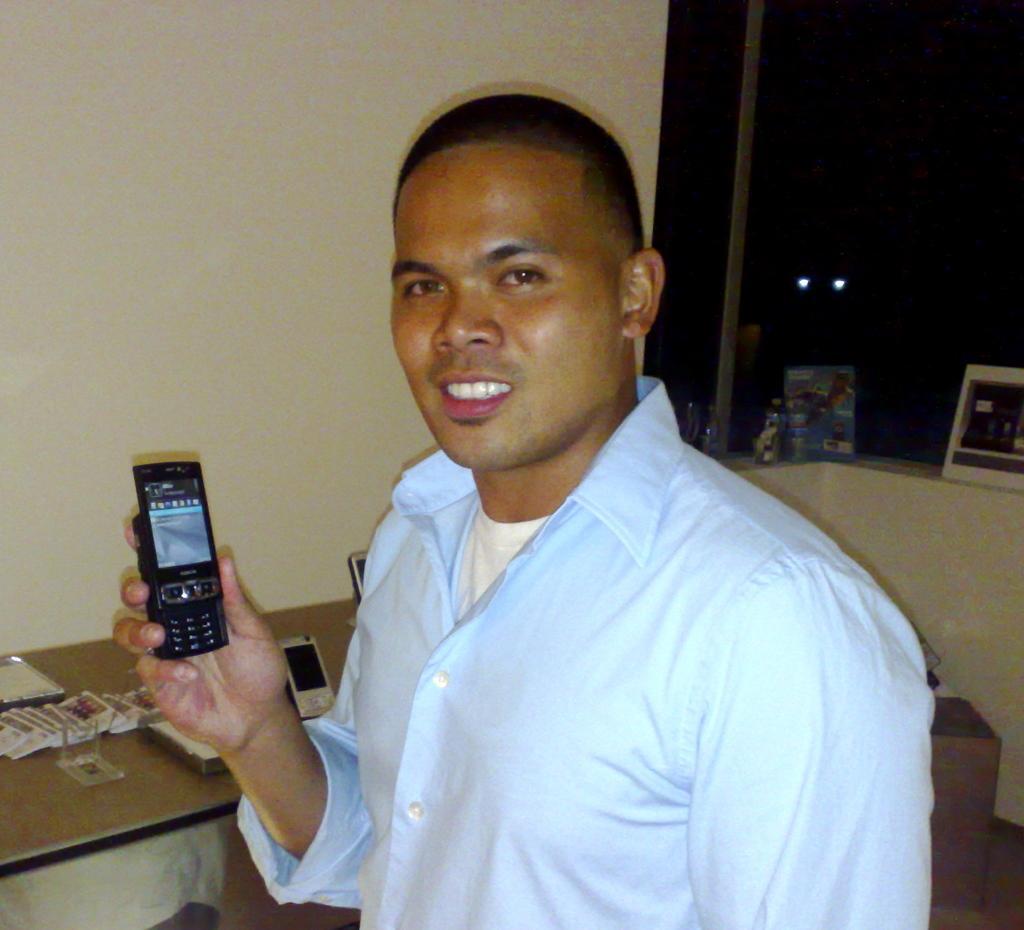Describe this image in one or two sentences. In this image a man is standing and holding a mobile phone in his hand. At the background there is a wall and a window. In the left side of the image there is a table and there were few things on it. 